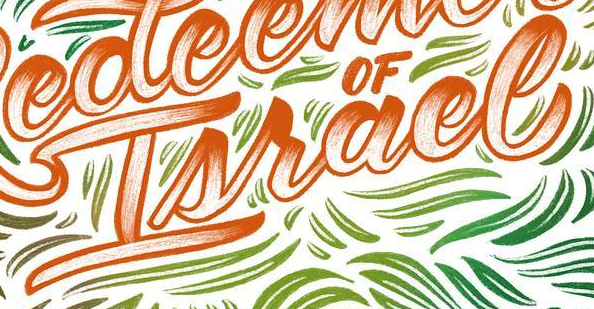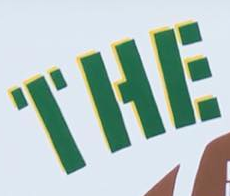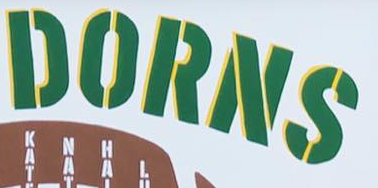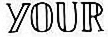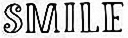Identify the words shown in these images in order, separated by a semicolon. Israel; THE; DORNS; YOUR; SMILE 